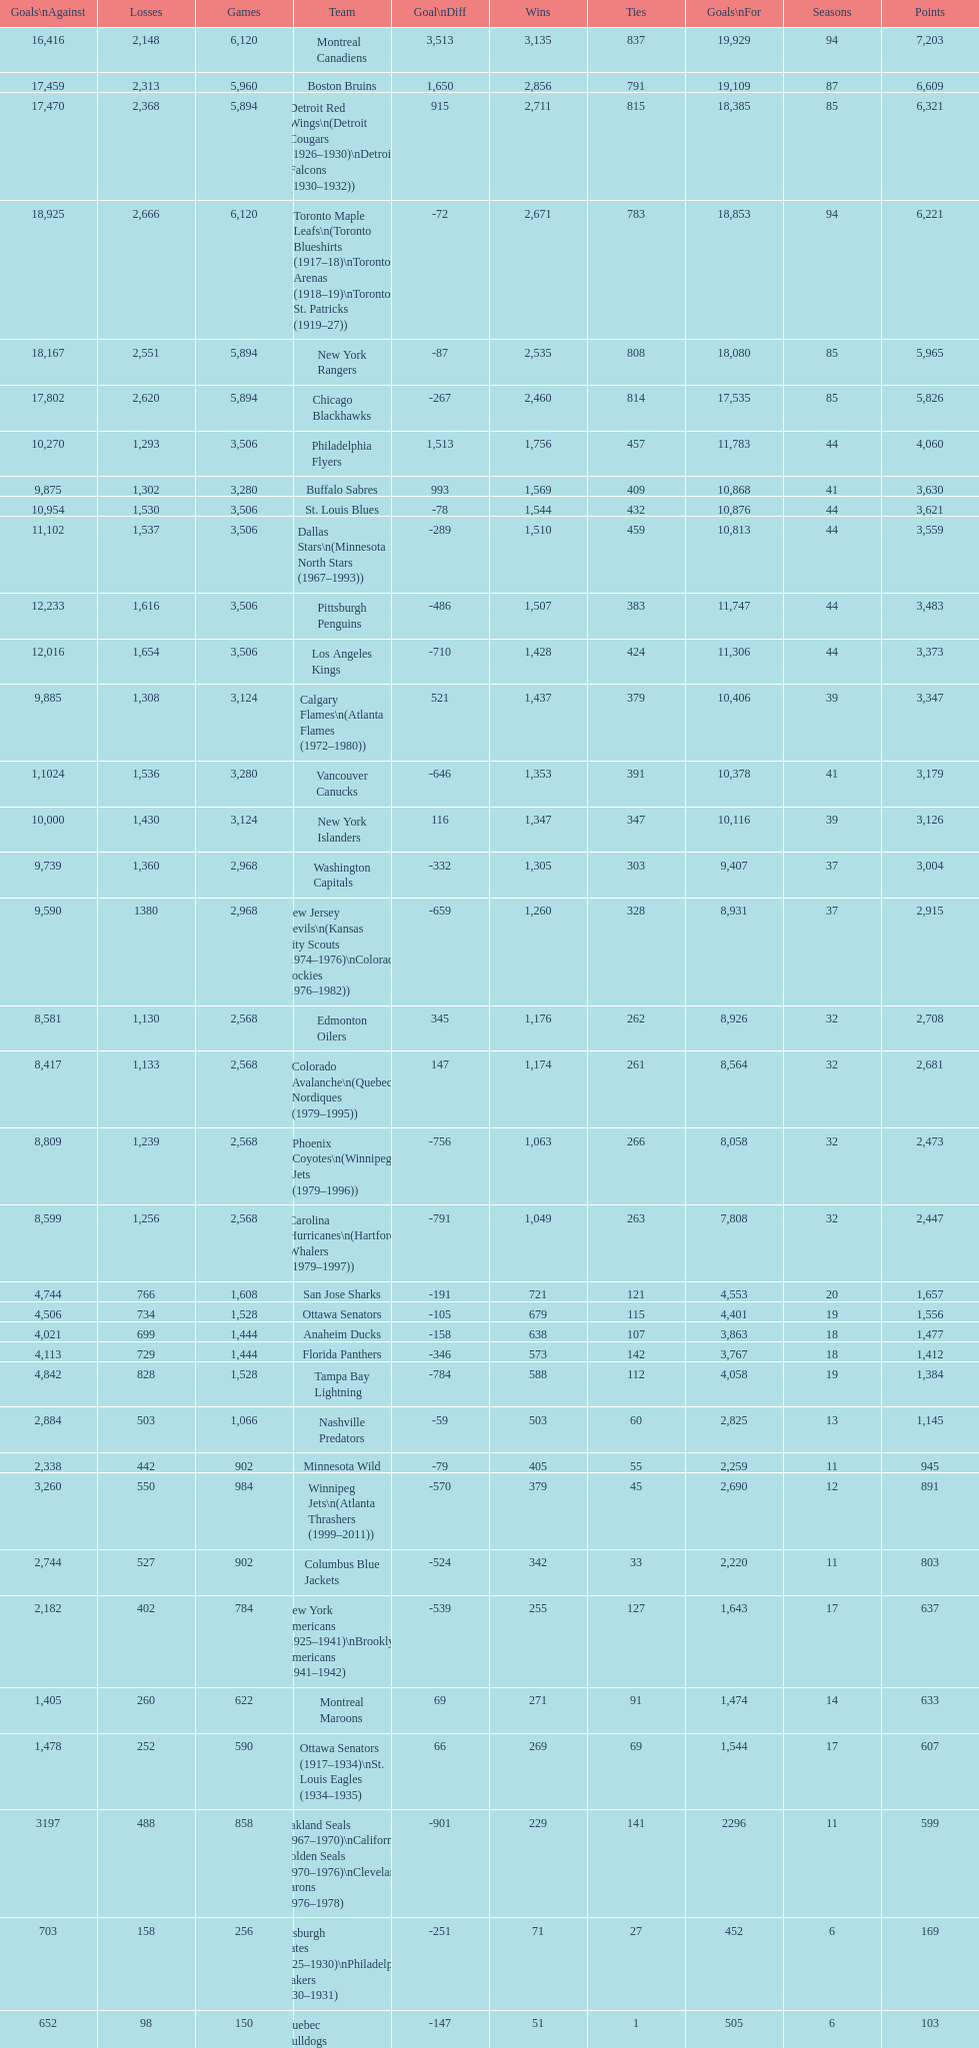How many total points has the lost angeles kings scored? 3,373. 